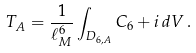<formula> <loc_0><loc_0><loc_500><loc_500>T _ { A } = \frac { 1 } { \ell _ { M } ^ { 6 } } \int _ { D _ { 6 , A } } C _ { 6 } + i \, d V \, .</formula> 